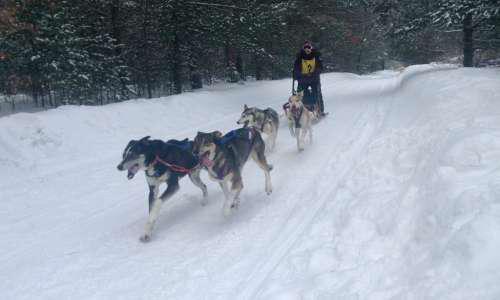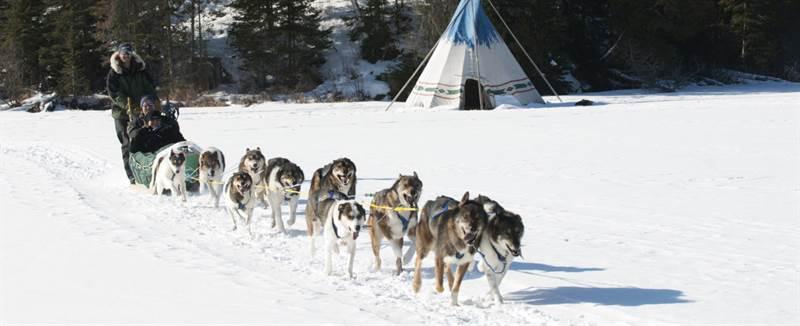The first image is the image on the left, the second image is the image on the right. Analyze the images presented: Is the assertion "A manmade shelter for people is in the background behind a sled dog team moving rightward." valid? Answer yes or no. Yes. The first image is the image on the left, the second image is the image on the right. Evaluate the accuracy of this statement regarding the images: "The left image contains exactly six sled dogs.". Is it true? Answer yes or no. No. 